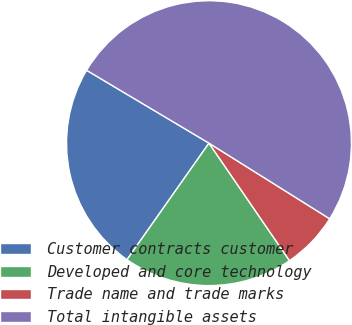<chart> <loc_0><loc_0><loc_500><loc_500><pie_chart><fcel>Customer contracts customer<fcel>Developed and core technology<fcel>Trade name and trade marks<fcel>Total intangible assets<nl><fcel>23.79%<fcel>19.32%<fcel>6.53%<fcel>50.36%<nl></chart> 